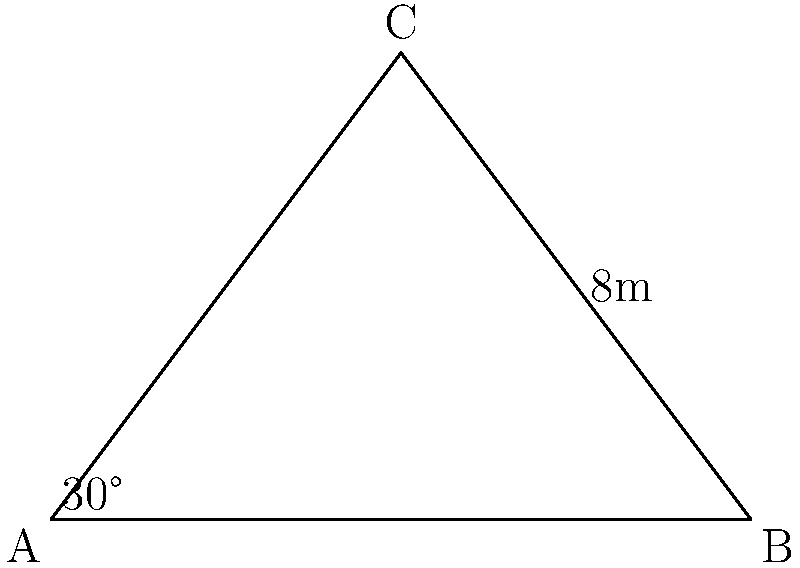In a pivotal scene, you need to position the camera at point C to capture the perfect shot. The camera is mounted on a tripod 4 meters high (point C), and its base is 3 meters away from a wall (point A to B). The angle between the ground and the camera's line of sight to point A is 30°. Calculate the distance from the camera (point C) to point A, which is crucial for adjusting the focus and framing the shot. Let's approach this step-by-step:

1) We can see that triangle ABC is a right-angled triangle, with the right angle at B.

2) We know the following:
   - The height of the camera (CB) is 4 meters
   - The distance from the wall to the tripod base (AB) is 3 meters
   - The angle CAB is 30°

3) To find the distance AC, we can use the trigonometric ratio tangent:

   $$\tan 30° = \frac{\text{opposite}}{\text{adjacent}} = \frac{CB}{AB} = \frac{4}{3}$$

4) We know that $\tan 30° = \frac{1}{\sqrt{3}}$, so we can verify:

   $$\frac{1}{\sqrt{3}} = \frac{4}{3}$$

5) Now, to find AC, we can use the Pythagorean theorem:

   $$AC^2 = AB^2 + CB^2$$

6) Substituting the known values:

   $$AC^2 = 3^2 + 4^2 = 9 + 16 = 25$$

7) Taking the square root of both sides:

   $$AC = \sqrt{25} = 5$$

Therefore, the distance from the camera (point C) to point A is 5 meters.
Answer: 5 meters 